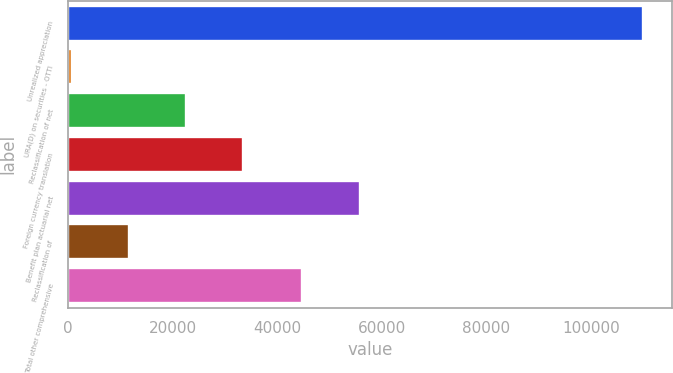Convert chart. <chart><loc_0><loc_0><loc_500><loc_500><bar_chart><fcel>Unrealized appreciation<fcel>URA(D) on securities - OTTI<fcel>Reclassification of net<fcel>Foreign currency translation<fcel>Benefit plan actuarial net<fcel>Reclassification of<fcel>Total other comprehensive<nl><fcel>109928<fcel>824<fcel>22644.8<fcel>33555.2<fcel>55730.4<fcel>11734.4<fcel>44820<nl></chart> 